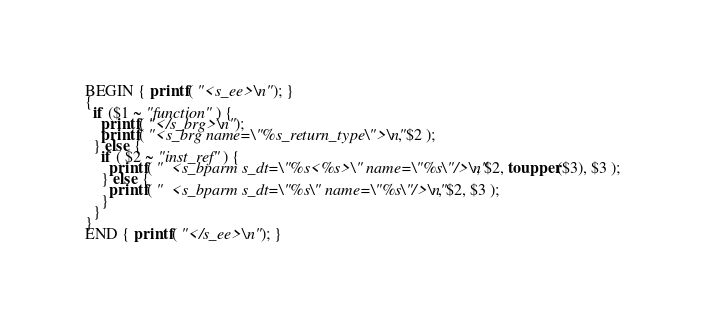<code> <loc_0><loc_0><loc_500><loc_500><_Awk_>BEGIN { printf( "<s_ee>\n" ); }
{
  if ($1 ~ "function" ) {
    printf( "</s_brg>\n" );
    printf( "<s_brg name=\"%s_return_type\">\n", $2 );
  } else {
    if ( $2 ~ "inst_ref" ) {
      printf( "  <s_bparm s_dt=\"%s<%s>\" name=\"%s\"/>\n", $2, toupper($3), $3 );
    } else {
      printf( "  <s_bparm s_dt=\"%s\" name=\"%s\"/>\n", $2, $3 );
    }
  }
}
END { printf( "</s_ee>\n" ); }
</code> 